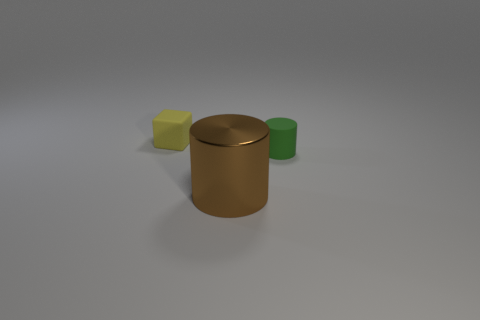Is the number of small green matte cylinders less than the number of green metallic cubes?
Ensure brevity in your answer.  No. What material is the block that is the same size as the green object?
Provide a short and direct response. Rubber. Is the number of small green cylinders greater than the number of green metal spheres?
Give a very brief answer. Yes. What number of other objects are there of the same color as the matte cylinder?
Your response must be concise. 0. What number of objects are in front of the small green object and behind the green object?
Ensure brevity in your answer.  0. Are there any other things that are the same size as the brown object?
Make the answer very short. No. Is the number of green matte cylinders that are on the right side of the green cylinder greater than the number of tiny things that are right of the small yellow object?
Your answer should be very brief. No. There is a small thing that is on the right side of the brown cylinder; what material is it?
Provide a short and direct response. Rubber. There is a green matte object; does it have the same shape as the big object that is in front of the cube?
Offer a very short reply. Yes. How many rubber things are to the left of the cylinder left of the tiny object that is to the right of the large brown object?
Make the answer very short. 1. 